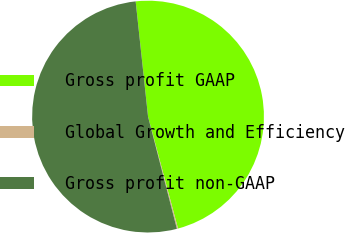Convert chart to OTSL. <chart><loc_0><loc_0><loc_500><loc_500><pie_chart><fcel>Gross profit GAAP<fcel>Global Growth and Efficiency<fcel>Gross profit non-GAAP<nl><fcel>47.54%<fcel>0.16%<fcel>52.3%<nl></chart> 